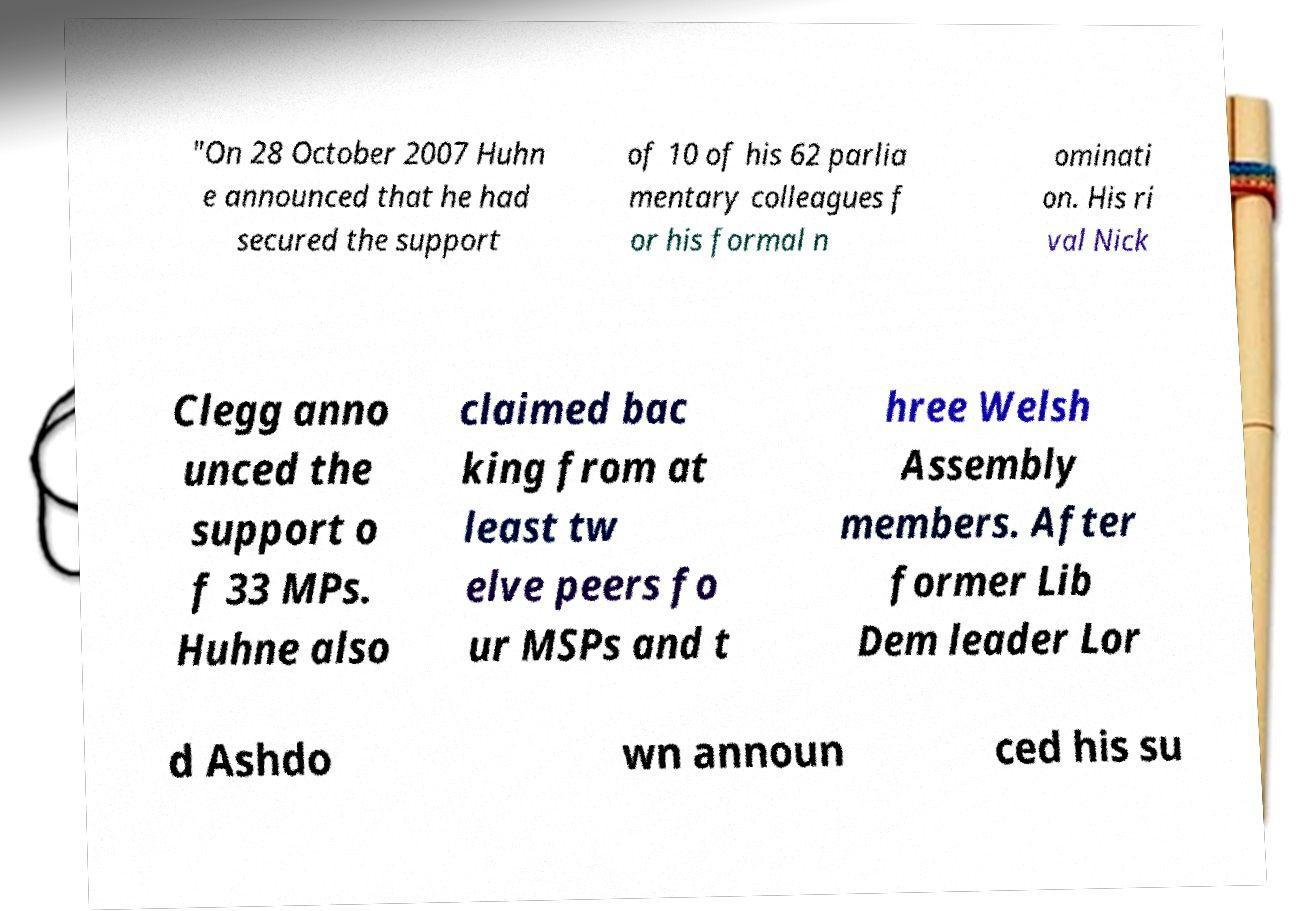Please identify and transcribe the text found in this image. "On 28 October 2007 Huhn e announced that he had secured the support of 10 of his 62 parlia mentary colleagues f or his formal n ominati on. His ri val Nick Clegg anno unced the support o f 33 MPs. Huhne also claimed bac king from at least tw elve peers fo ur MSPs and t hree Welsh Assembly members. After former Lib Dem leader Lor d Ashdo wn announ ced his su 